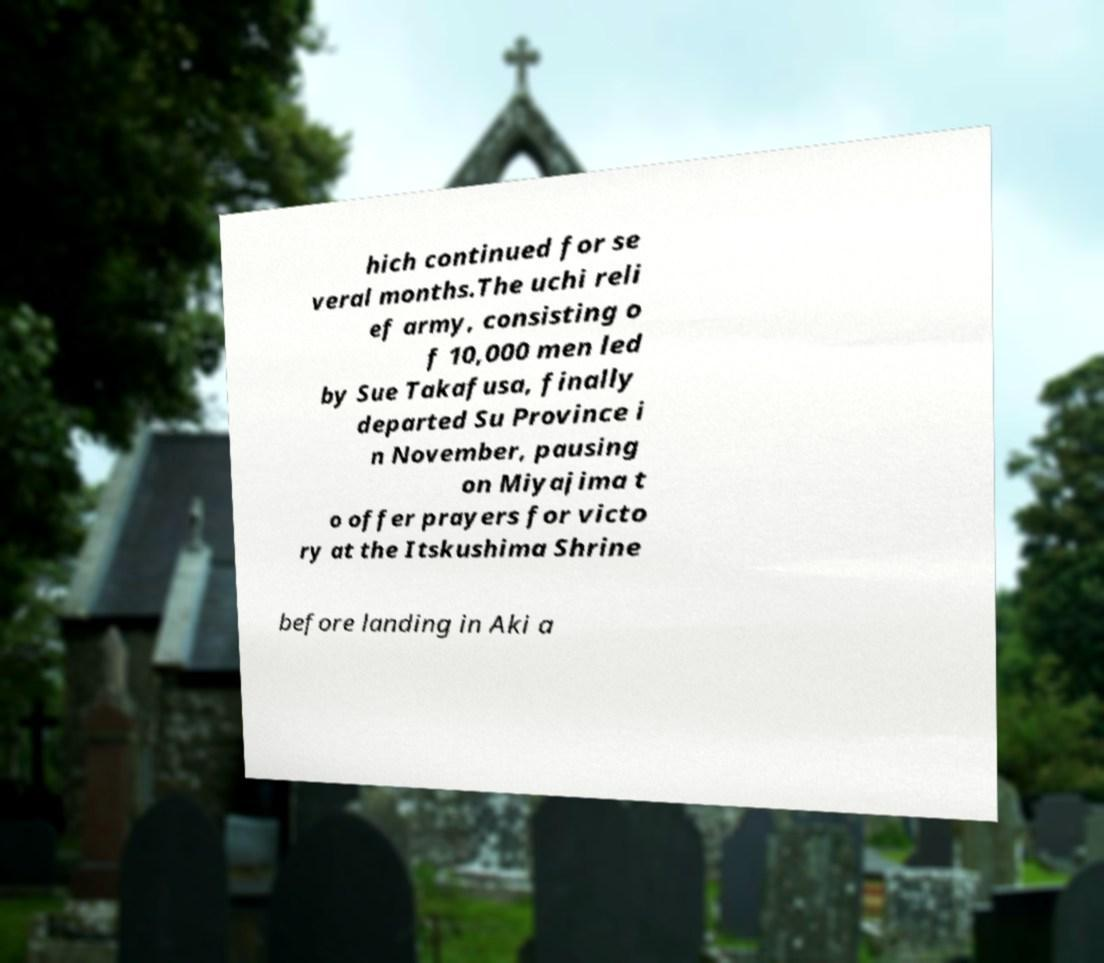Could you assist in decoding the text presented in this image and type it out clearly? hich continued for se veral months.The uchi reli ef army, consisting o f 10,000 men led by Sue Takafusa, finally departed Su Province i n November, pausing on Miyajima t o offer prayers for victo ry at the Itskushima Shrine before landing in Aki a 